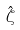Convert formula to latex. <formula><loc_0><loc_0><loc_500><loc_500>\hat { \zeta }</formula> 